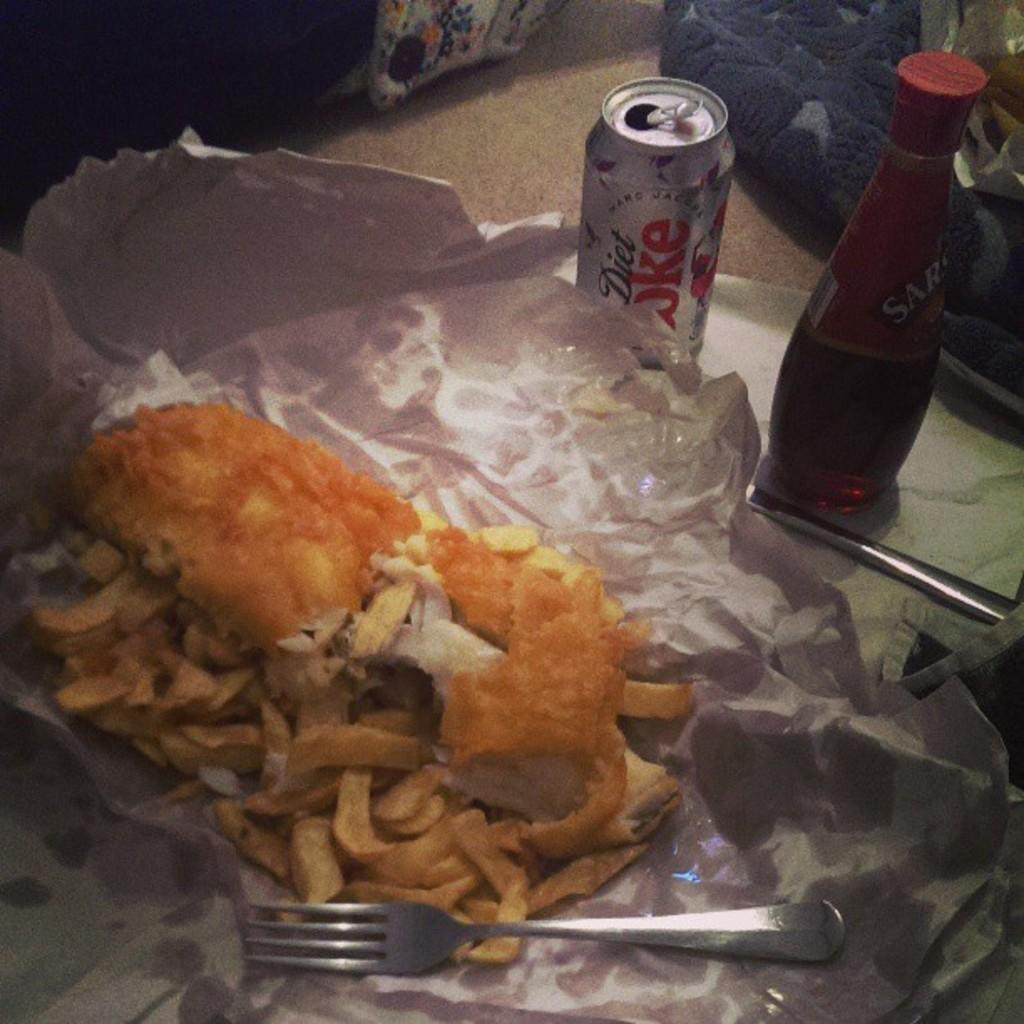<image>
Describe the image concisely. A can of Diet Coke sits next to a messy sandwich. 